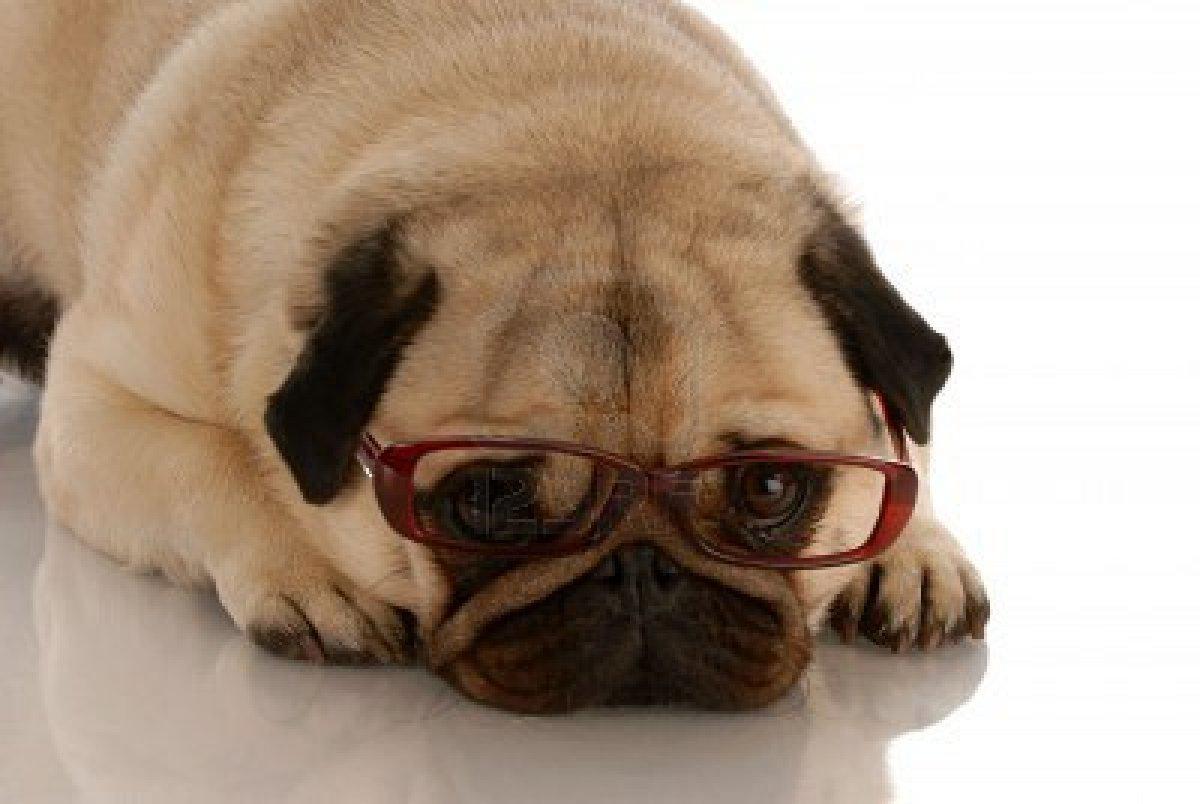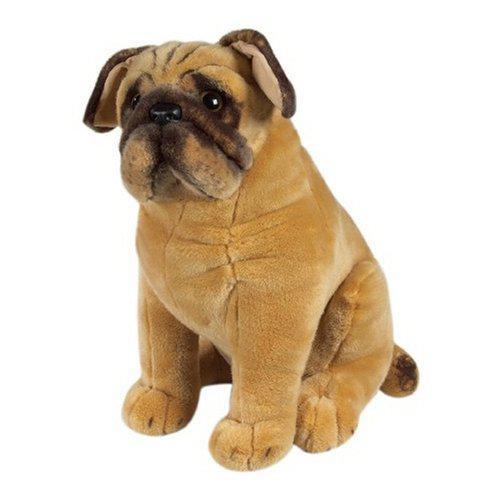The first image is the image on the left, the second image is the image on the right. Evaluate the accuracy of this statement regarding the images: "One of the images is not a living creature.". Is it true? Answer yes or no. Yes. The first image is the image on the left, the second image is the image on the right. For the images displayed, is the sentence "The left and right image contains the same number of living pugs." factually correct? Answer yes or no. No. 